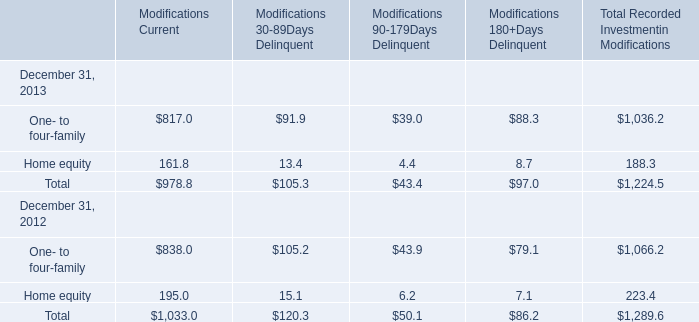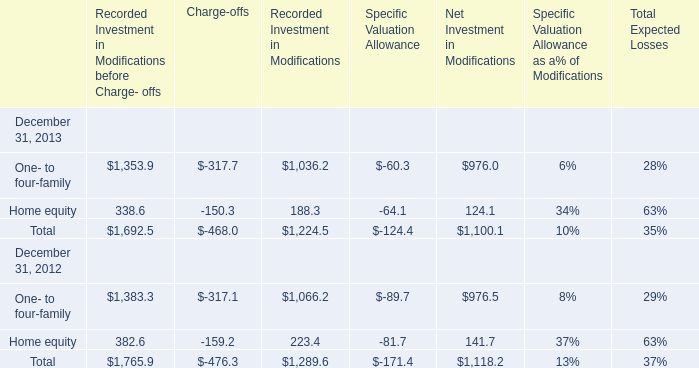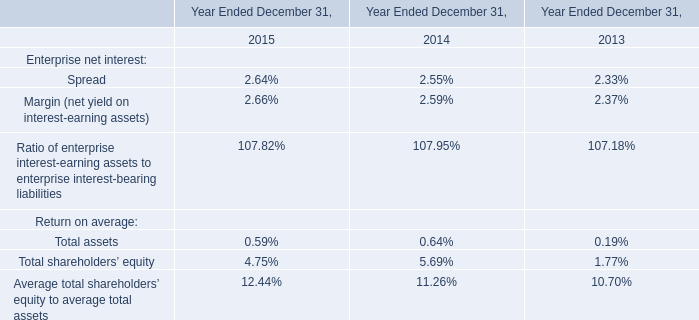What was the average value of the Total Net Investment in Modifications in the years where One- to four-family's Recorded Investment in Modifications before Charge- offs is positive? 
Computations: ((1100.1 + 1118.2) / 2)
Answer: 1109.15. 